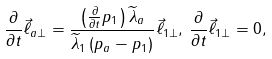Convert formula to latex. <formula><loc_0><loc_0><loc_500><loc_500>\frac { \partial } { \partial t } \vec { \ell } _ { a \perp } = \frac { \left ( \frac { \partial } { \partial t } p _ { 1 } \right ) \widetilde { \lambda } _ { a } } { \widetilde { \lambda } _ { 1 } \left ( p _ { a } - p _ { 1 } \right ) } \vec { \ell } _ { 1 \perp } , \, \frac { \partial } { \partial t } \vec { \ell } _ { 1 \perp } = 0 ,</formula> 